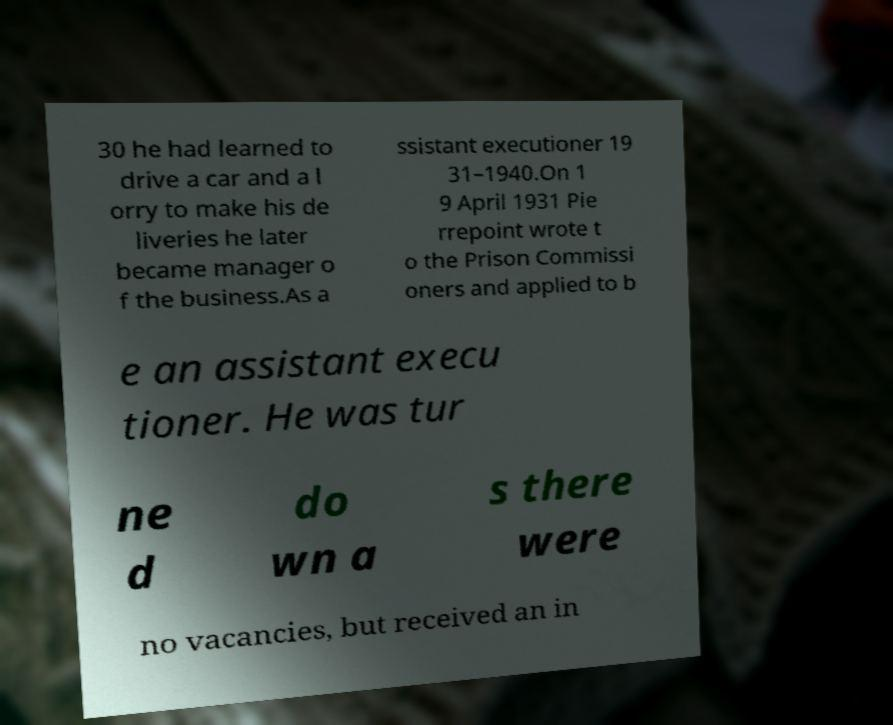Please read and relay the text visible in this image. What does it say? 30 he had learned to drive a car and a l orry to make his de liveries he later became manager o f the business.As a ssistant executioner 19 31–1940.On 1 9 April 1931 Pie rrepoint wrote t o the Prison Commissi oners and applied to b e an assistant execu tioner. He was tur ne d do wn a s there were no vacancies, but received an in 